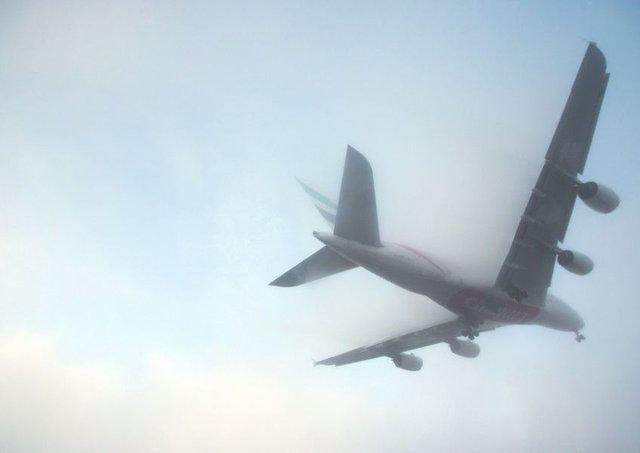Is there an aeroplane in the image? Yes, there is an aeroplane in the image. It appears to be flying, captured from a perspective looking up towards the sky with a backdrop of hazy or misty conditions, which diffuses the sunlight. 